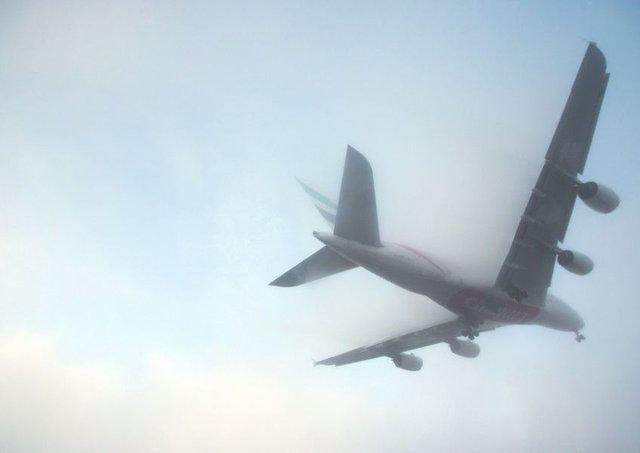Is there an aeroplane in the image? Yes, there is an aeroplane in the image. It appears to be flying, captured from a perspective looking up towards the sky with a backdrop of hazy or misty conditions, which diffuses the sunlight. 